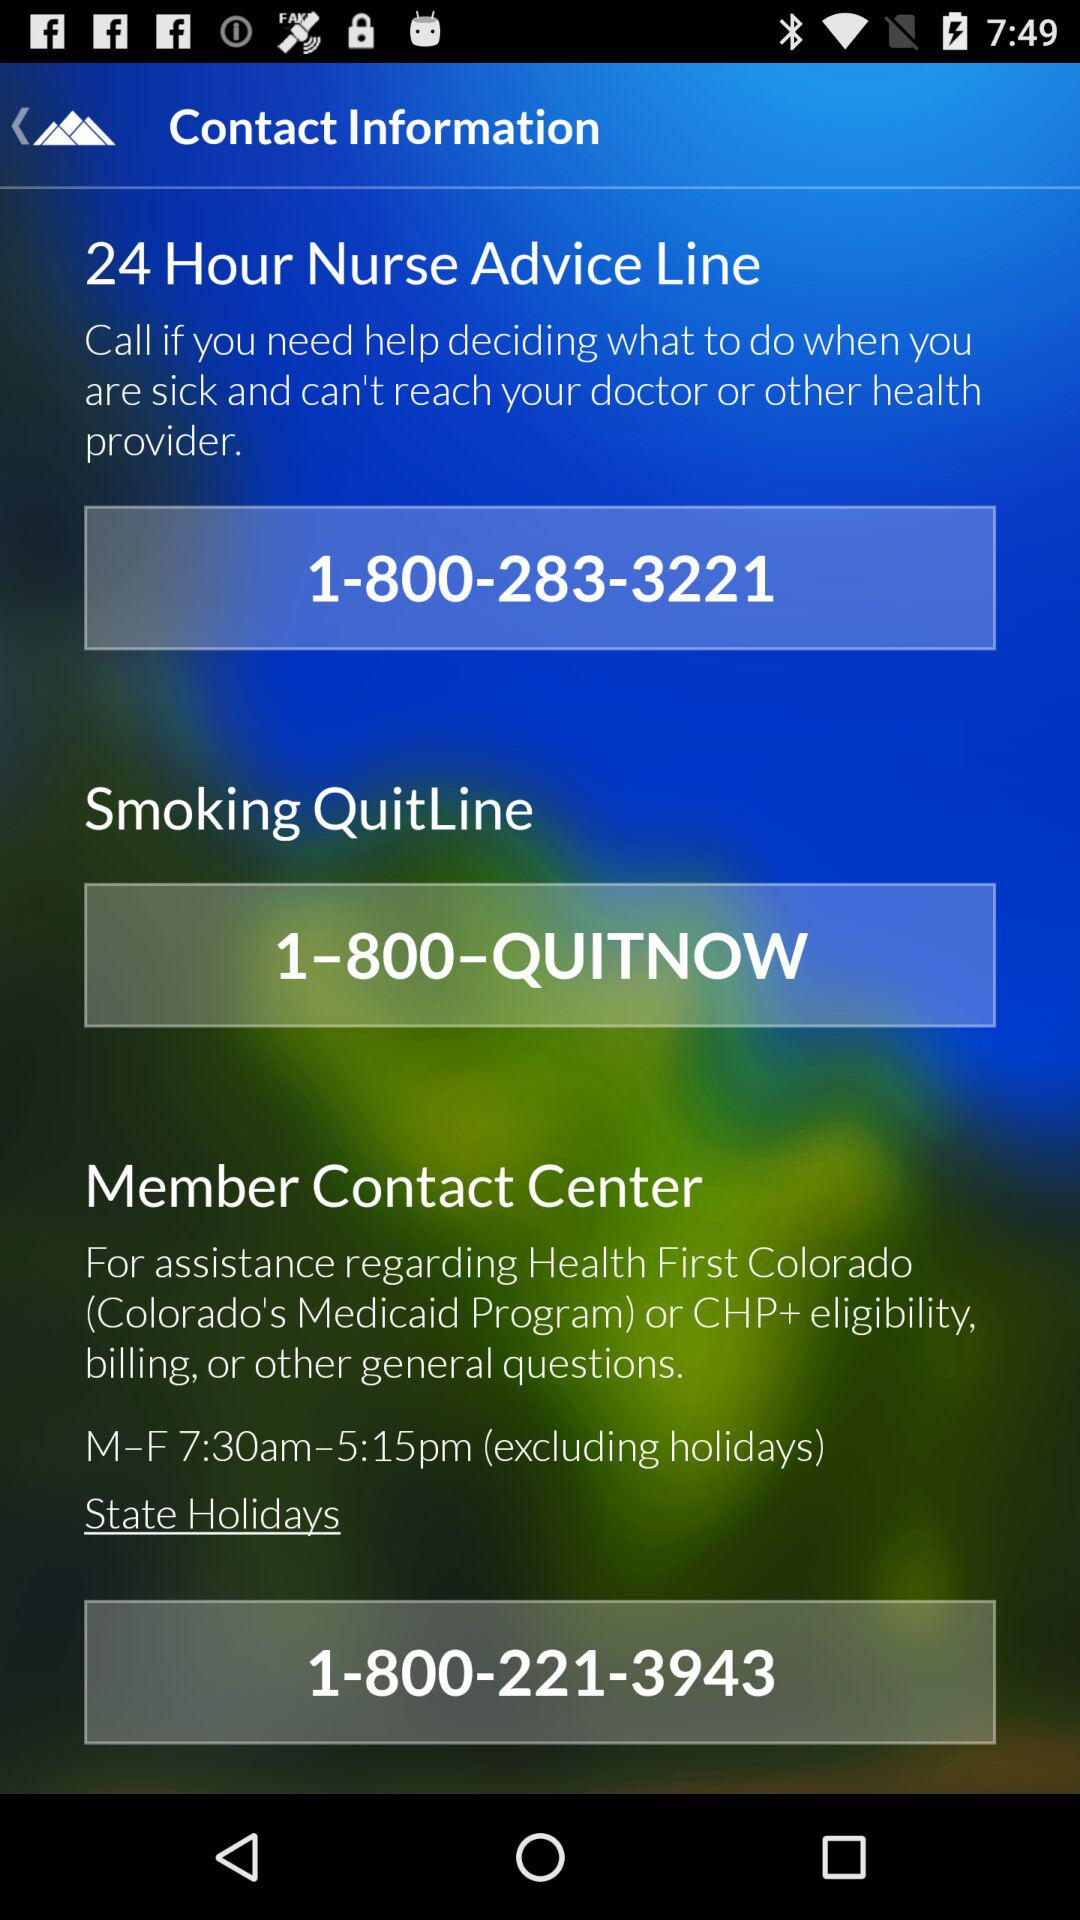What are the working days for the "Member Contact Center"? The working days for the "Member Contact Center" are Monday to Friday. 